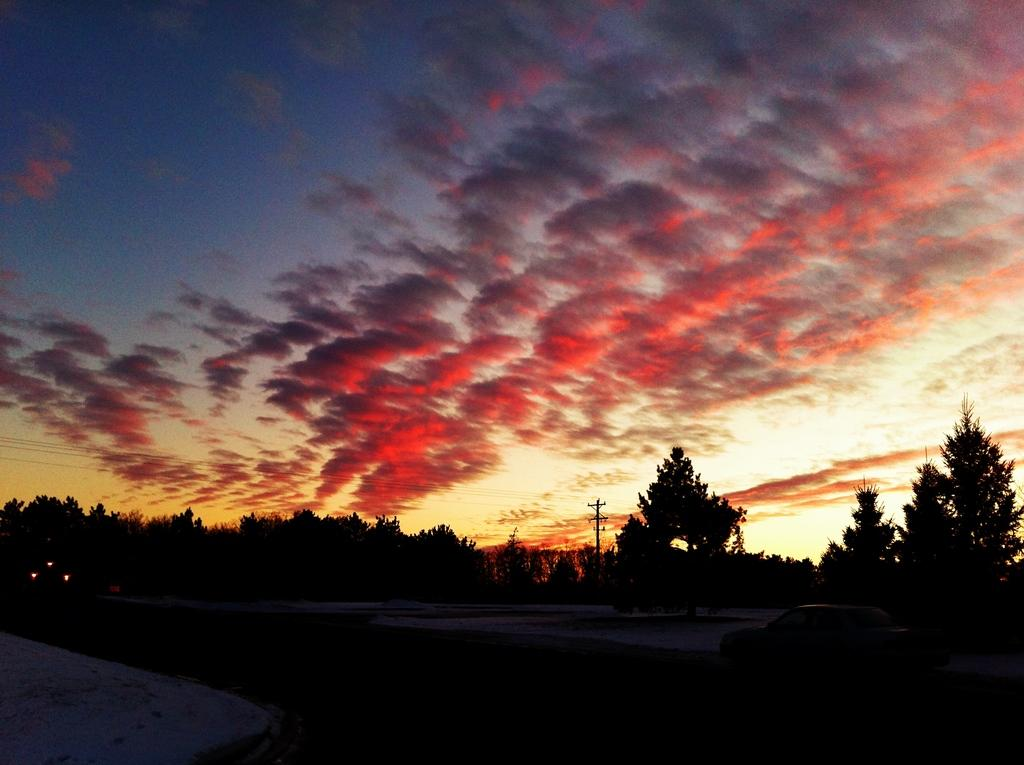What is the main subject of the image? There is a car in the image. What other objects can be seen in the image? There are trees and a utility pole visible in the image. What is visible in the background of the image? The sky is visible in the image. What type of crow can be seen perched on the utility pole in the image? There is no crow present in the image; it only features a car, trees, a utility pole, and the sky. What form of transportation is the orange vehicle in the image? There is no orange vehicle in the image; the car is not described as being orange. 